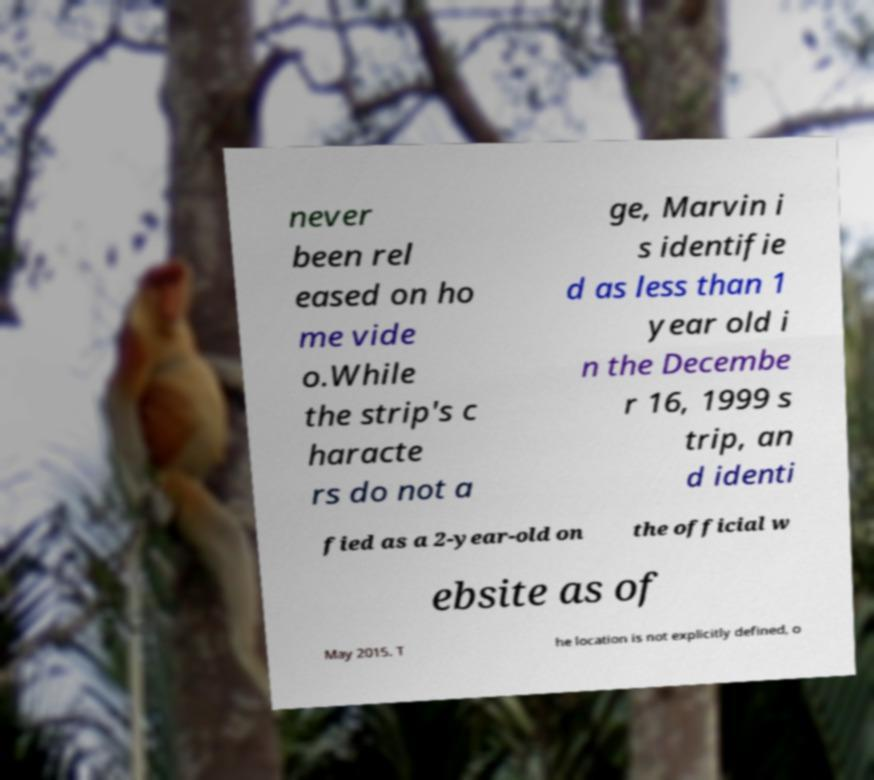There's text embedded in this image that I need extracted. Can you transcribe it verbatim? never been rel eased on ho me vide o.While the strip's c haracte rs do not a ge, Marvin i s identifie d as less than 1 year old i n the Decembe r 16, 1999 s trip, an d identi fied as a 2-year-old on the official w ebsite as of May 2015. T he location is not explicitly defined, o 